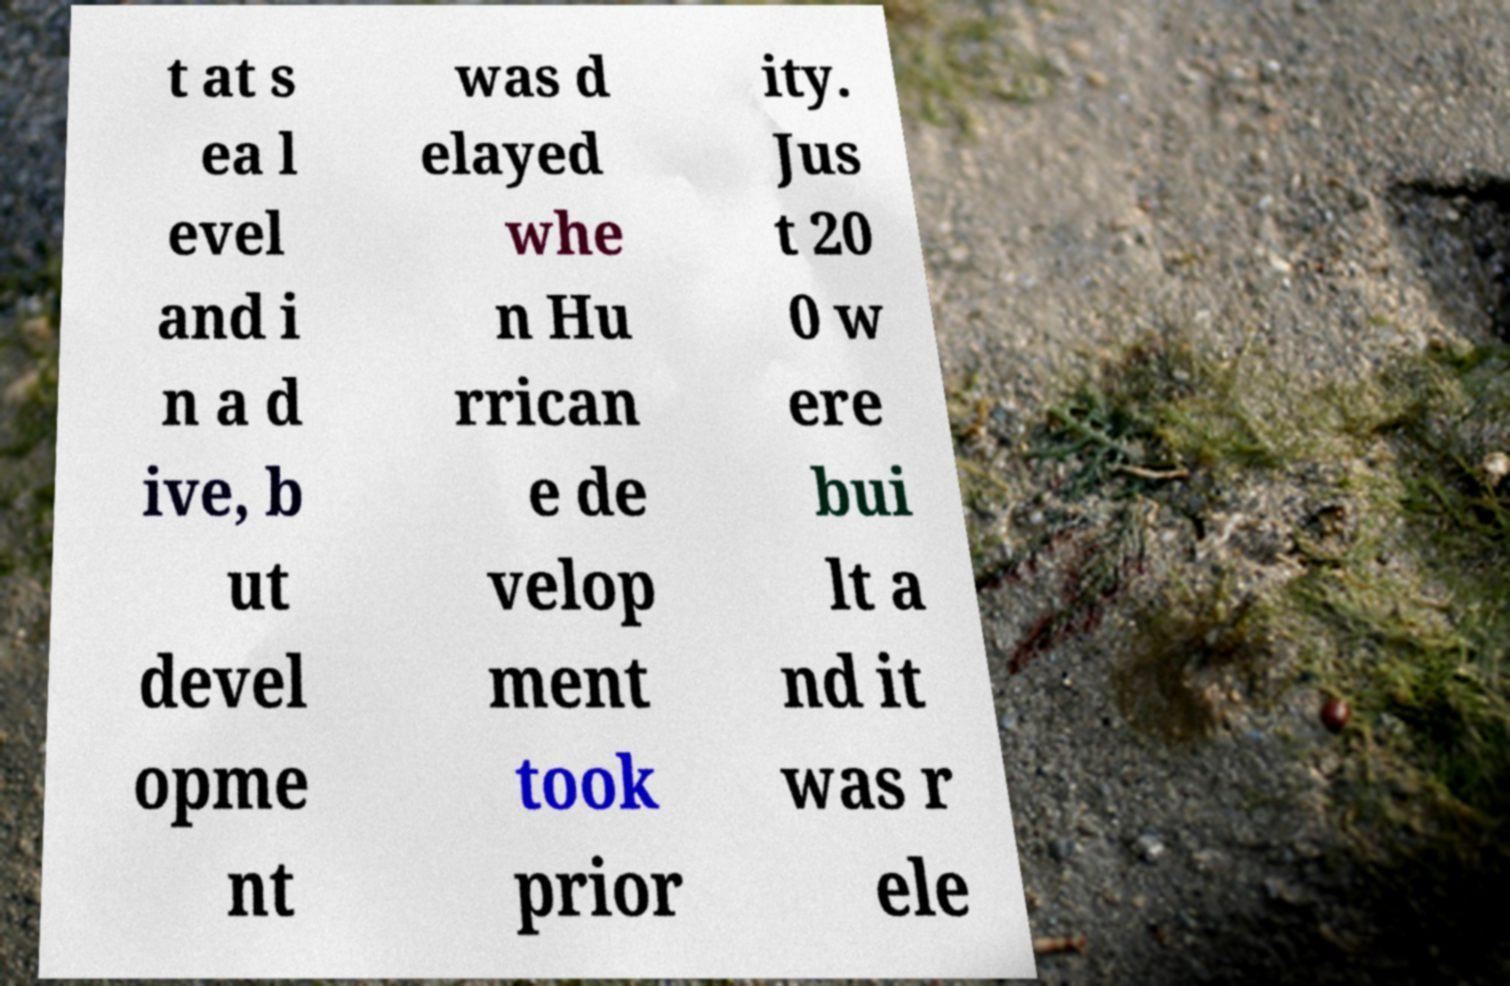There's text embedded in this image that I need extracted. Can you transcribe it verbatim? t at s ea l evel and i n a d ive, b ut devel opme nt was d elayed whe n Hu rrican e de velop ment took prior ity. Jus t 20 0 w ere bui lt a nd it was r ele 